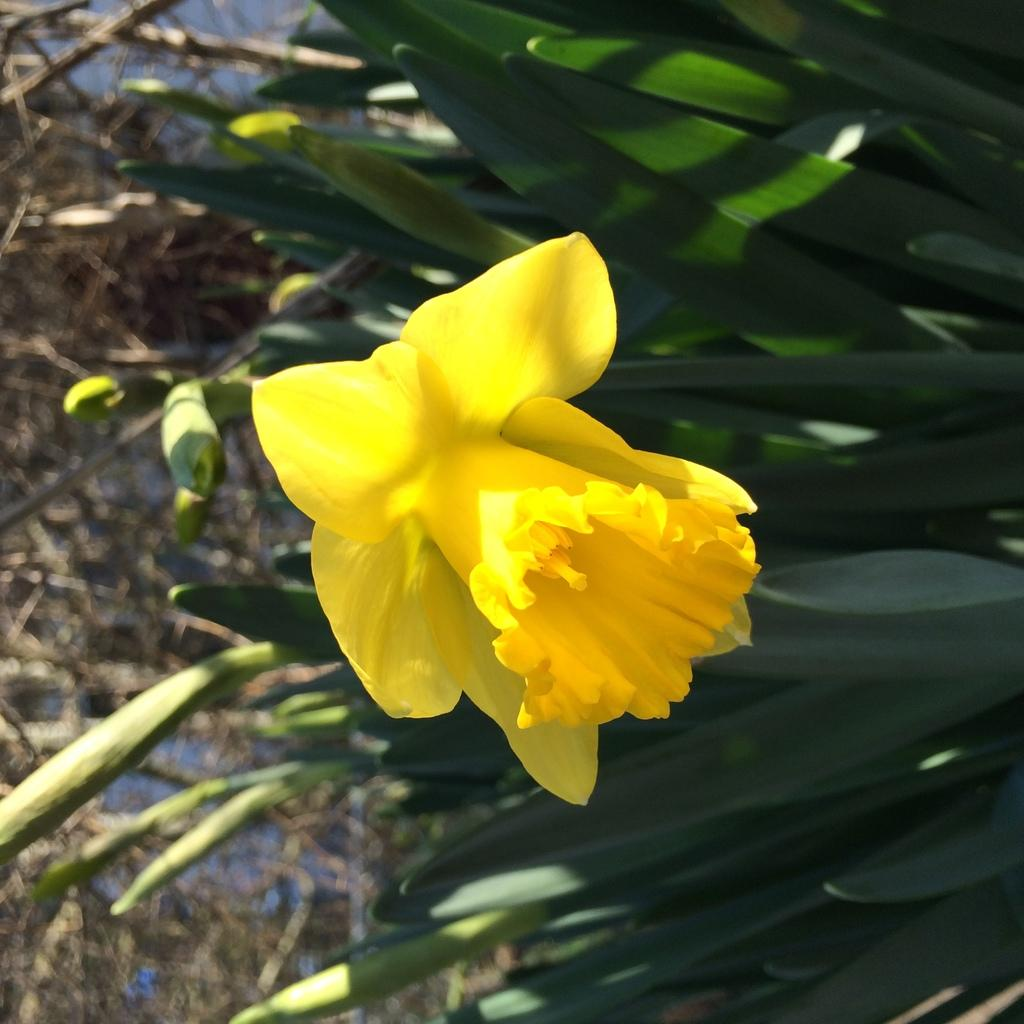What is present in the image? There is a plant in the image. What feature of the plant is mentioned? The plant contains a flower. Can you see a snail climbing on the plant in the image? There is no snail present in the image; it only features a plant with a flower. 